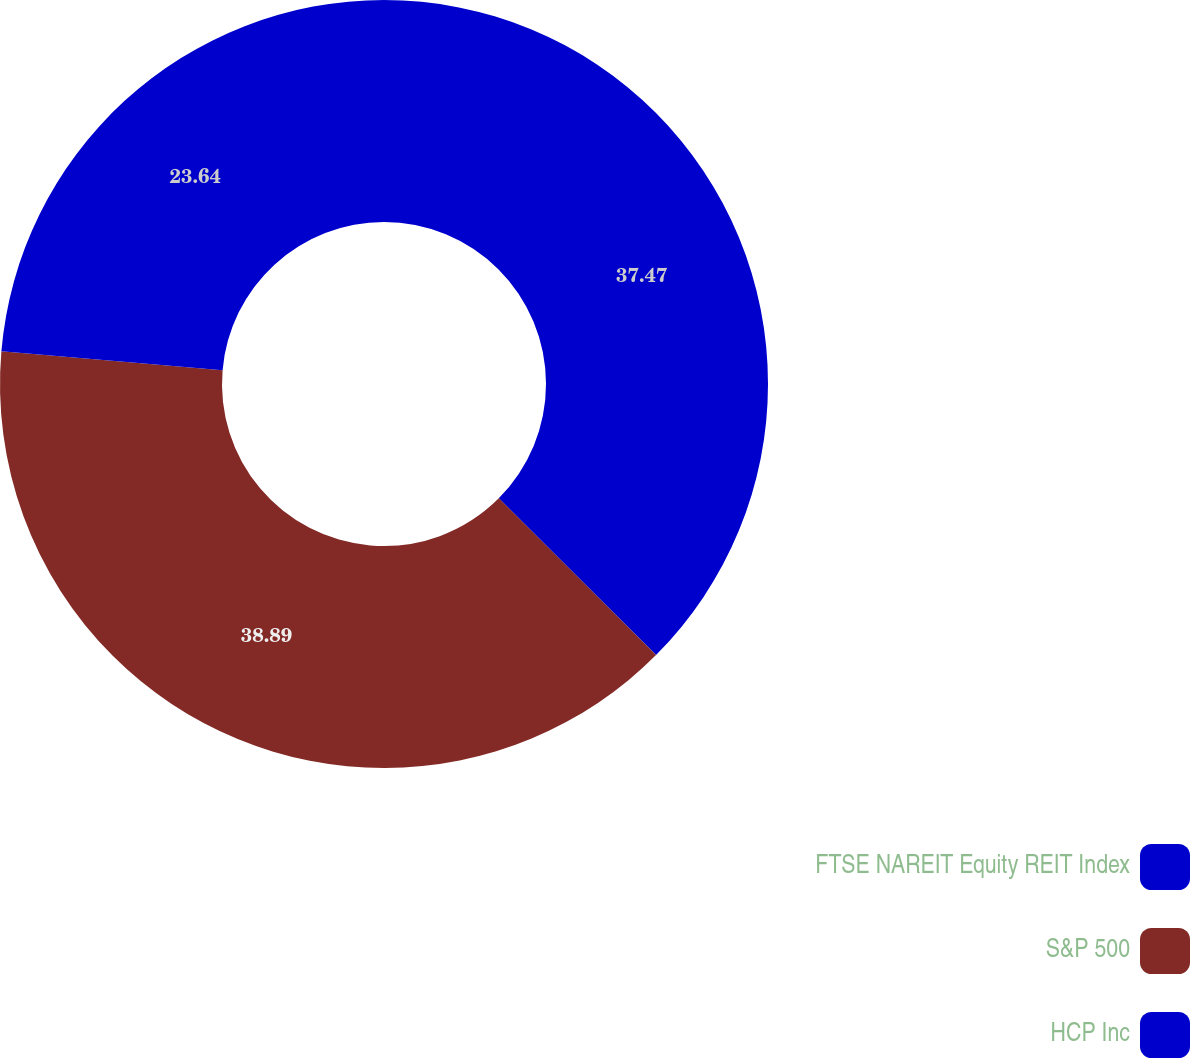Convert chart to OTSL. <chart><loc_0><loc_0><loc_500><loc_500><pie_chart><fcel>FTSE NAREIT Equity REIT Index<fcel>S&P 500<fcel>HCP Inc<nl><fcel>37.47%<fcel>38.89%<fcel>23.64%<nl></chart> 